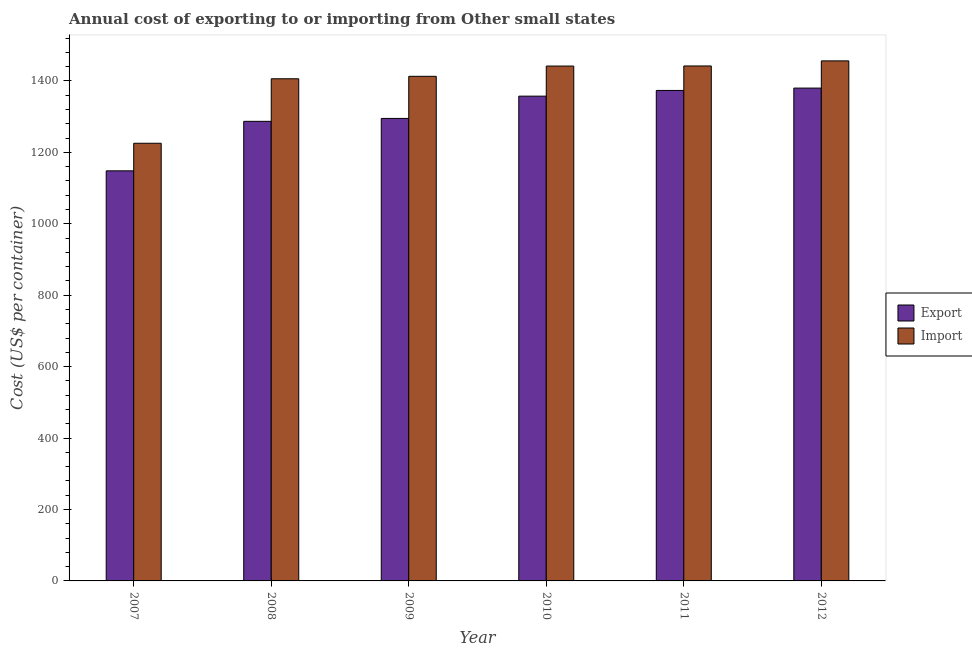What is the label of the 4th group of bars from the left?
Keep it short and to the point. 2010. In how many cases, is the number of bars for a given year not equal to the number of legend labels?
Your answer should be compact. 0. What is the import cost in 2010?
Your response must be concise. 1441.67. Across all years, what is the maximum import cost?
Your answer should be very brief. 1456.17. Across all years, what is the minimum export cost?
Your answer should be compact. 1148.28. In which year was the export cost minimum?
Offer a very short reply. 2007. What is the total export cost in the graph?
Provide a succinct answer. 7840.94. What is the difference between the import cost in 2008 and that in 2010?
Your answer should be compact. -35.61. What is the difference between the import cost in 2011 and the export cost in 2009?
Your answer should be compact. 29. What is the average export cost per year?
Ensure brevity in your answer.  1306.82. What is the ratio of the export cost in 2007 to that in 2011?
Your answer should be very brief. 0.84. Is the difference between the export cost in 2008 and 2009 greater than the difference between the import cost in 2008 and 2009?
Offer a very short reply. No. What is the difference between the highest and the second highest export cost?
Keep it short and to the point. 6.61. What is the difference between the highest and the lowest export cost?
Your answer should be compact. 231.72. In how many years, is the import cost greater than the average import cost taken over all years?
Ensure brevity in your answer.  5. What does the 1st bar from the left in 2010 represents?
Provide a short and direct response. Export. What does the 2nd bar from the right in 2012 represents?
Offer a terse response. Export. How many bars are there?
Keep it short and to the point. 12. How many years are there in the graph?
Keep it short and to the point. 6. Are the values on the major ticks of Y-axis written in scientific E-notation?
Your answer should be very brief. No. Does the graph contain grids?
Give a very brief answer. No. Where does the legend appear in the graph?
Ensure brevity in your answer.  Center right. How many legend labels are there?
Offer a very short reply. 2. How are the legend labels stacked?
Offer a terse response. Vertical. What is the title of the graph?
Provide a succinct answer. Annual cost of exporting to or importing from Other small states. Does "Secondary Education" appear as one of the legend labels in the graph?
Provide a short and direct response. No. What is the label or title of the Y-axis?
Make the answer very short. Cost (US$ per container). What is the Cost (US$ per container) of Export in 2007?
Offer a very short reply. 1148.28. What is the Cost (US$ per container) of Import in 2007?
Make the answer very short. 1225.5. What is the Cost (US$ per container) of Export in 2008?
Your answer should be very brief. 1286.89. What is the Cost (US$ per container) in Import in 2008?
Your answer should be very brief. 1406.06. What is the Cost (US$ per container) in Export in 2009?
Provide a succinct answer. 1295. What is the Cost (US$ per container) in Import in 2009?
Ensure brevity in your answer.  1412.94. What is the Cost (US$ per container) of Export in 2010?
Keep it short and to the point. 1357.39. What is the Cost (US$ per container) in Import in 2010?
Offer a terse response. 1441.67. What is the Cost (US$ per container) in Export in 2011?
Your answer should be very brief. 1373.39. What is the Cost (US$ per container) in Import in 2011?
Ensure brevity in your answer.  1441.94. What is the Cost (US$ per container) in Export in 2012?
Your answer should be very brief. 1380. What is the Cost (US$ per container) in Import in 2012?
Make the answer very short. 1456.17. Across all years, what is the maximum Cost (US$ per container) in Export?
Provide a succinct answer. 1380. Across all years, what is the maximum Cost (US$ per container) of Import?
Provide a short and direct response. 1456.17. Across all years, what is the minimum Cost (US$ per container) in Export?
Your answer should be very brief. 1148.28. Across all years, what is the minimum Cost (US$ per container) of Import?
Your answer should be compact. 1225.5. What is the total Cost (US$ per container) in Export in the graph?
Provide a succinct answer. 7840.94. What is the total Cost (US$ per container) of Import in the graph?
Offer a very short reply. 8384.28. What is the difference between the Cost (US$ per container) in Export in 2007 and that in 2008?
Your answer should be very brief. -138.61. What is the difference between the Cost (US$ per container) in Import in 2007 and that in 2008?
Offer a very short reply. -180.56. What is the difference between the Cost (US$ per container) of Export in 2007 and that in 2009?
Ensure brevity in your answer.  -146.72. What is the difference between the Cost (US$ per container) of Import in 2007 and that in 2009?
Offer a very short reply. -187.44. What is the difference between the Cost (US$ per container) in Export in 2007 and that in 2010?
Offer a very short reply. -209.11. What is the difference between the Cost (US$ per container) in Import in 2007 and that in 2010?
Offer a terse response. -216.17. What is the difference between the Cost (US$ per container) in Export in 2007 and that in 2011?
Offer a very short reply. -225.11. What is the difference between the Cost (US$ per container) of Import in 2007 and that in 2011?
Offer a very short reply. -216.44. What is the difference between the Cost (US$ per container) in Export in 2007 and that in 2012?
Keep it short and to the point. -231.72. What is the difference between the Cost (US$ per container) of Import in 2007 and that in 2012?
Your response must be concise. -230.67. What is the difference between the Cost (US$ per container) of Export in 2008 and that in 2009?
Offer a terse response. -8.11. What is the difference between the Cost (US$ per container) of Import in 2008 and that in 2009?
Provide a short and direct response. -6.89. What is the difference between the Cost (US$ per container) of Export in 2008 and that in 2010?
Make the answer very short. -70.5. What is the difference between the Cost (US$ per container) in Import in 2008 and that in 2010?
Your response must be concise. -35.61. What is the difference between the Cost (US$ per container) of Export in 2008 and that in 2011?
Offer a very short reply. -86.5. What is the difference between the Cost (US$ per container) in Import in 2008 and that in 2011?
Give a very brief answer. -35.89. What is the difference between the Cost (US$ per container) of Export in 2008 and that in 2012?
Your answer should be compact. -93.11. What is the difference between the Cost (US$ per container) in Import in 2008 and that in 2012?
Provide a succinct answer. -50.11. What is the difference between the Cost (US$ per container) of Export in 2009 and that in 2010?
Keep it short and to the point. -62.39. What is the difference between the Cost (US$ per container) in Import in 2009 and that in 2010?
Your response must be concise. -28.72. What is the difference between the Cost (US$ per container) in Export in 2009 and that in 2011?
Make the answer very short. -78.39. What is the difference between the Cost (US$ per container) in Export in 2009 and that in 2012?
Give a very brief answer. -85. What is the difference between the Cost (US$ per container) in Import in 2009 and that in 2012?
Your answer should be very brief. -43.22. What is the difference between the Cost (US$ per container) in Export in 2010 and that in 2011?
Offer a very short reply. -16. What is the difference between the Cost (US$ per container) in Import in 2010 and that in 2011?
Provide a succinct answer. -0.28. What is the difference between the Cost (US$ per container) of Export in 2010 and that in 2012?
Give a very brief answer. -22.61. What is the difference between the Cost (US$ per container) of Import in 2010 and that in 2012?
Offer a terse response. -14.5. What is the difference between the Cost (US$ per container) in Export in 2011 and that in 2012?
Ensure brevity in your answer.  -6.61. What is the difference between the Cost (US$ per container) in Import in 2011 and that in 2012?
Offer a very short reply. -14.22. What is the difference between the Cost (US$ per container) of Export in 2007 and the Cost (US$ per container) of Import in 2008?
Give a very brief answer. -257.78. What is the difference between the Cost (US$ per container) in Export in 2007 and the Cost (US$ per container) in Import in 2009?
Ensure brevity in your answer.  -264.67. What is the difference between the Cost (US$ per container) of Export in 2007 and the Cost (US$ per container) of Import in 2010?
Offer a very short reply. -293.39. What is the difference between the Cost (US$ per container) of Export in 2007 and the Cost (US$ per container) of Import in 2011?
Keep it short and to the point. -293.67. What is the difference between the Cost (US$ per container) in Export in 2007 and the Cost (US$ per container) in Import in 2012?
Your answer should be very brief. -307.89. What is the difference between the Cost (US$ per container) of Export in 2008 and the Cost (US$ per container) of Import in 2009?
Give a very brief answer. -126.06. What is the difference between the Cost (US$ per container) in Export in 2008 and the Cost (US$ per container) in Import in 2010?
Give a very brief answer. -154.78. What is the difference between the Cost (US$ per container) in Export in 2008 and the Cost (US$ per container) in Import in 2011?
Ensure brevity in your answer.  -155.06. What is the difference between the Cost (US$ per container) of Export in 2008 and the Cost (US$ per container) of Import in 2012?
Ensure brevity in your answer.  -169.28. What is the difference between the Cost (US$ per container) in Export in 2009 and the Cost (US$ per container) in Import in 2010?
Provide a short and direct response. -146.67. What is the difference between the Cost (US$ per container) in Export in 2009 and the Cost (US$ per container) in Import in 2011?
Provide a short and direct response. -146.94. What is the difference between the Cost (US$ per container) in Export in 2009 and the Cost (US$ per container) in Import in 2012?
Your answer should be compact. -161.17. What is the difference between the Cost (US$ per container) of Export in 2010 and the Cost (US$ per container) of Import in 2011?
Provide a succinct answer. -84.56. What is the difference between the Cost (US$ per container) in Export in 2010 and the Cost (US$ per container) in Import in 2012?
Provide a succinct answer. -98.78. What is the difference between the Cost (US$ per container) of Export in 2011 and the Cost (US$ per container) of Import in 2012?
Your answer should be compact. -82.78. What is the average Cost (US$ per container) of Export per year?
Provide a short and direct response. 1306.82. What is the average Cost (US$ per container) of Import per year?
Your answer should be compact. 1397.38. In the year 2007, what is the difference between the Cost (US$ per container) of Export and Cost (US$ per container) of Import?
Provide a succinct answer. -77.22. In the year 2008, what is the difference between the Cost (US$ per container) of Export and Cost (US$ per container) of Import?
Ensure brevity in your answer.  -119.17. In the year 2009, what is the difference between the Cost (US$ per container) in Export and Cost (US$ per container) in Import?
Keep it short and to the point. -117.94. In the year 2010, what is the difference between the Cost (US$ per container) of Export and Cost (US$ per container) of Import?
Your response must be concise. -84.28. In the year 2011, what is the difference between the Cost (US$ per container) of Export and Cost (US$ per container) of Import?
Your answer should be very brief. -68.56. In the year 2012, what is the difference between the Cost (US$ per container) of Export and Cost (US$ per container) of Import?
Your response must be concise. -76.17. What is the ratio of the Cost (US$ per container) in Export in 2007 to that in 2008?
Provide a short and direct response. 0.89. What is the ratio of the Cost (US$ per container) in Import in 2007 to that in 2008?
Your response must be concise. 0.87. What is the ratio of the Cost (US$ per container) in Export in 2007 to that in 2009?
Provide a short and direct response. 0.89. What is the ratio of the Cost (US$ per container) of Import in 2007 to that in 2009?
Offer a very short reply. 0.87. What is the ratio of the Cost (US$ per container) of Export in 2007 to that in 2010?
Keep it short and to the point. 0.85. What is the ratio of the Cost (US$ per container) of Import in 2007 to that in 2010?
Keep it short and to the point. 0.85. What is the ratio of the Cost (US$ per container) of Export in 2007 to that in 2011?
Your answer should be compact. 0.84. What is the ratio of the Cost (US$ per container) of Import in 2007 to that in 2011?
Your answer should be very brief. 0.85. What is the ratio of the Cost (US$ per container) of Export in 2007 to that in 2012?
Give a very brief answer. 0.83. What is the ratio of the Cost (US$ per container) of Import in 2007 to that in 2012?
Give a very brief answer. 0.84. What is the ratio of the Cost (US$ per container) in Export in 2008 to that in 2010?
Your answer should be very brief. 0.95. What is the ratio of the Cost (US$ per container) of Import in 2008 to that in 2010?
Your response must be concise. 0.98. What is the ratio of the Cost (US$ per container) in Export in 2008 to that in 2011?
Provide a short and direct response. 0.94. What is the ratio of the Cost (US$ per container) of Import in 2008 to that in 2011?
Give a very brief answer. 0.98. What is the ratio of the Cost (US$ per container) of Export in 2008 to that in 2012?
Provide a short and direct response. 0.93. What is the ratio of the Cost (US$ per container) in Import in 2008 to that in 2012?
Your answer should be compact. 0.97. What is the ratio of the Cost (US$ per container) of Export in 2009 to that in 2010?
Give a very brief answer. 0.95. What is the ratio of the Cost (US$ per container) in Import in 2009 to that in 2010?
Your answer should be very brief. 0.98. What is the ratio of the Cost (US$ per container) of Export in 2009 to that in 2011?
Your answer should be very brief. 0.94. What is the ratio of the Cost (US$ per container) of Import in 2009 to that in 2011?
Your answer should be compact. 0.98. What is the ratio of the Cost (US$ per container) of Export in 2009 to that in 2012?
Provide a succinct answer. 0.94. What is the ratio of the Cost (US$ per container) of Import in 2009 to that in 2012?
Offer a terse response. 0.97. What is the ratio of the Cost (US$ per container) in Export in 2010 to that in 2011?
Your answer should be very brief. 0.99. What is the ratio of the Cost (US$ per container) of Export in 2010 to that in 2012?
Provide a succinct answer. 0.98. What is the ratio of the Cost (US$ per container) in Import in 2010 to that in 2012?
Ensure brevity in your answer.  0.99. What is the ratio of the Cost (US$ per container) in Export in 2011 to that in 2012?
Give a very brief answer. 1. What is the ratio of the Cost (US$ per container) in Import in 2011 to that in 2012?
Your answer should be very brief. 0.99. What is the difference between the highest and the second highest Cost (US$ per container) of Export?
Provide a short and direct response. 6.61. What is the difference between the highest and the second highest Cost (US$ per container) in Import?
Offer a terse response. 14.22. What is the difference between the highest and the lowest Cost (US$ per container) of Export?
Your answer should be very brief. 231.72. What is the difference between the highest and the lowest Cost (US$ per container) in Import?
Give a very brief answer. 230.67. 